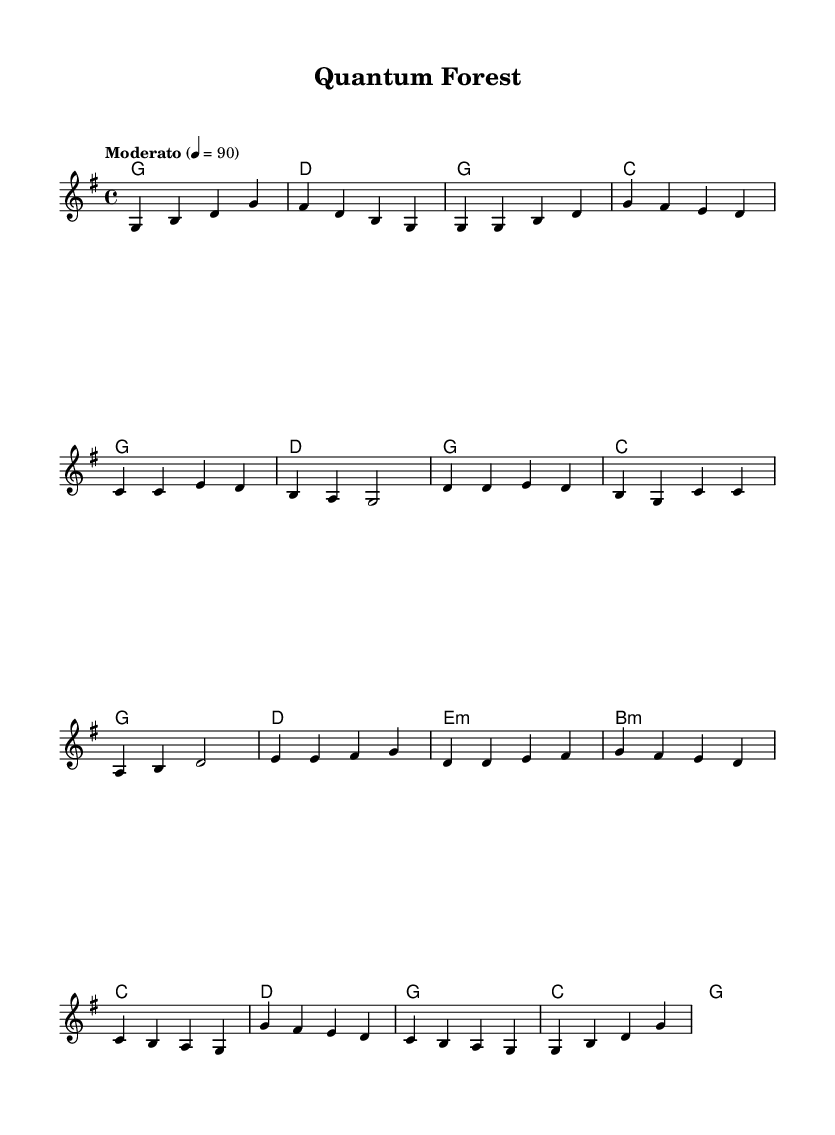What is the key signature of this music? The key signature indicates the number of sharps or flats in a piece; in this case, the absence of any sharps or flats suggests that the key signature is G major.
Answer: G major What is the time signature of this piece? The time signature is represented in the beginning of the musical score; here, it shows 4/4, which means there are four beats in each measure and the quarter note gets one beat.
Answer: 4/4 What tempo marking is indicated? The tempo marking is specified above the staff and reads "Moderato," which indicates a moderate speed. The metronome marking of 90 confirms this.
Answer: Moderato How many measures are in the verse section? By counting the measures from the melody line in the verse portion, we find there are 4 measures indicated by the musical notation.
Answer: 4 What chord follows the initial G major chord in the intro? The harmonies show that after the G major chord, the next chord is D major, meaning D follows G in the intro.
Answer: D What is the chord progression used during the chorus? By looking at the harmonies listed for the chorus section, we see the progression is G, C, G, D, which indicates the sequence of chords played during the chorus.
Answer: G, C, G, D What is the emotional tone suggested by the use of nature themes in the lyrics? The combination of natural imagery and technology themes typically invites introspection and connection with the environment, suggesting a harmonious blend or conflict between nature and human innovation.
Answer: Harmonious blend 